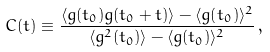<formula> <loc_0><loc_0><loc_500><loc_500>C ( t ) \equiv \frac { \langle g ( t _ { 0 } ) g ( t _ { 0 } + t ) \rangle - \langle g ( t _ { 0 } ) \rangle ^ { 2 } } { \langle g ^ { 2 } ( t _ { 0 } ) \rangle - \langle g ( t _ { 0 } ) \rangle ^ { 2 } } \, ,</formula> 